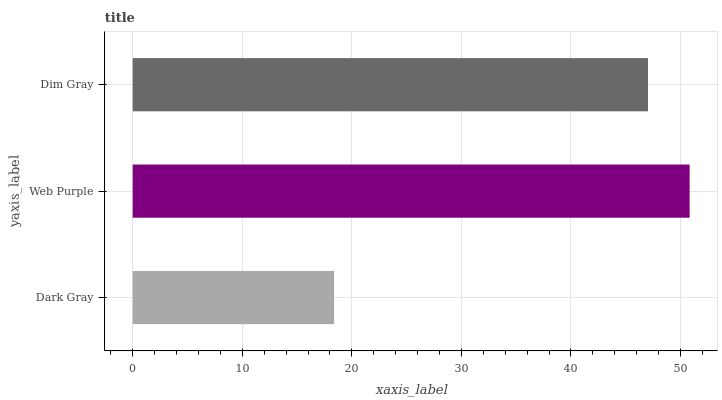Is Dark Gray the minimum?
Answer yes or no. Yes. Is Web Purple the maximum?
Answer yes or no. Yes. Is Dim Gray the minimum?
Answer yes or no. No. Is Dim Gray the maximum?
Answer yes or no. No. Is Web Purple greater than Dim Gray?
Answer yes or no. Yes. Is Dim Gray less than Web Purple?
Answer yes or no. Yes. Is Dim Gray greater than Web Purple?
Answer yes or no. No. Is Web Purple less than Dim Gray?
Answer yes or no. No. Is Dim Gray the high median?
Answer yes or no. Yes. Is Dim Gray the low median?
Answer yes or no. Yes. Is Dark Gray the high median?
Answer yes or no. No. Is Dark Gray the low median?
Answer yes or no. No. 